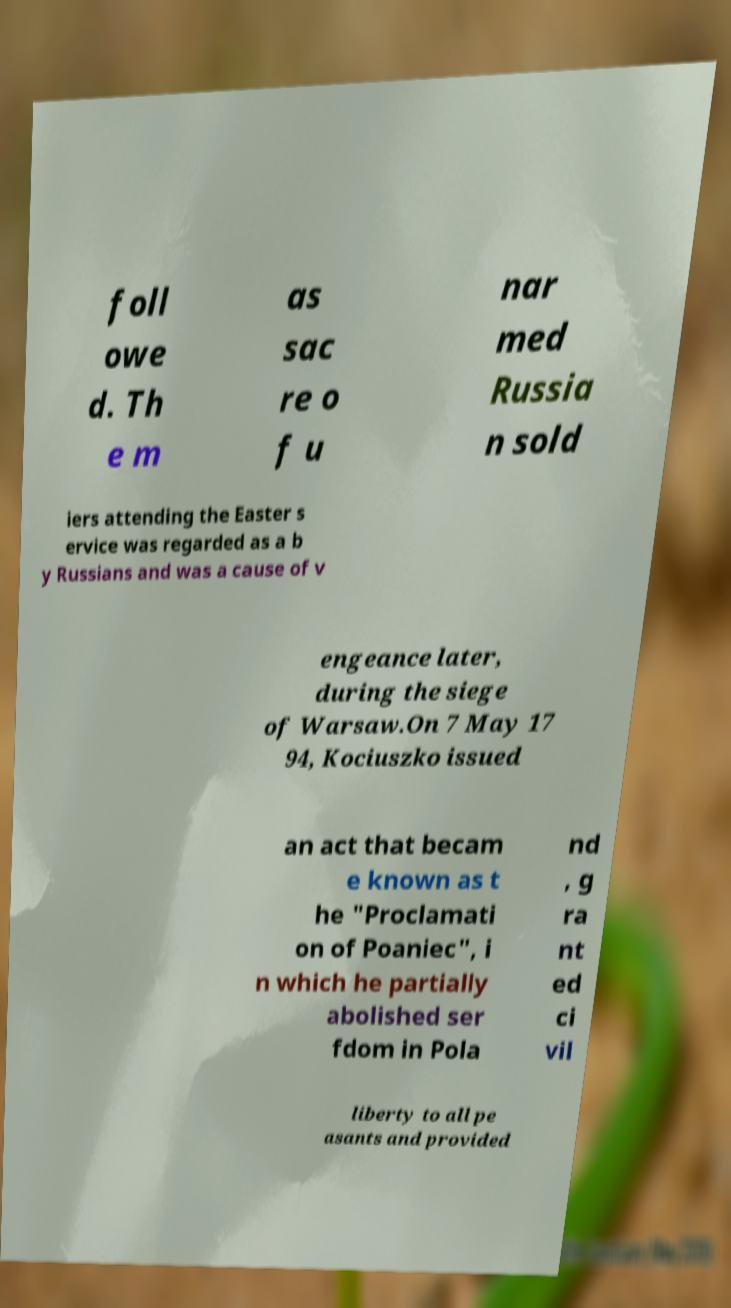Can you read and provide the text displayed in the image?This photo seems to have some interesting text. Can you extract and type it out for me? foll owe d. Th e m as sac re o f u nar med Russia n sold iers attending the Easter s ervice was regarded as a b y Russians and was a cause of v engeance later, during the siege of Warsaw.On 7 May 17 94, Kociuszko issued an act that becam e known as t he "Proclamati on of Poaniec", i n which he partially abolished ser fdom in Pola nd , g ra nt ed ci vil liberty to all pe asants and provided 